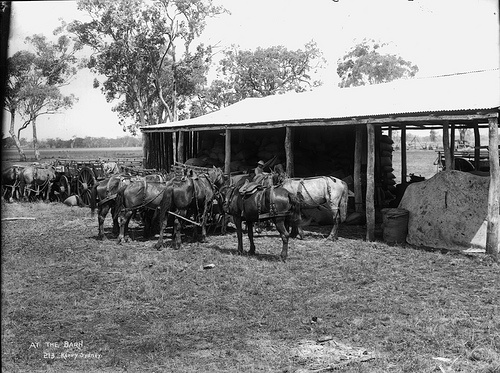Describe the objects in this image and their specific colors. I can see horse in black, gray, darkgray, and lightgray tones, horse in black, gray, darkgray, and lightgray tones, horse in black, gray, lightgray, and darkgray tones, horse in black, gray, darkgray, and lightgray tones, and horse in black, gray, darkgray, and lightgray tones in this image. 